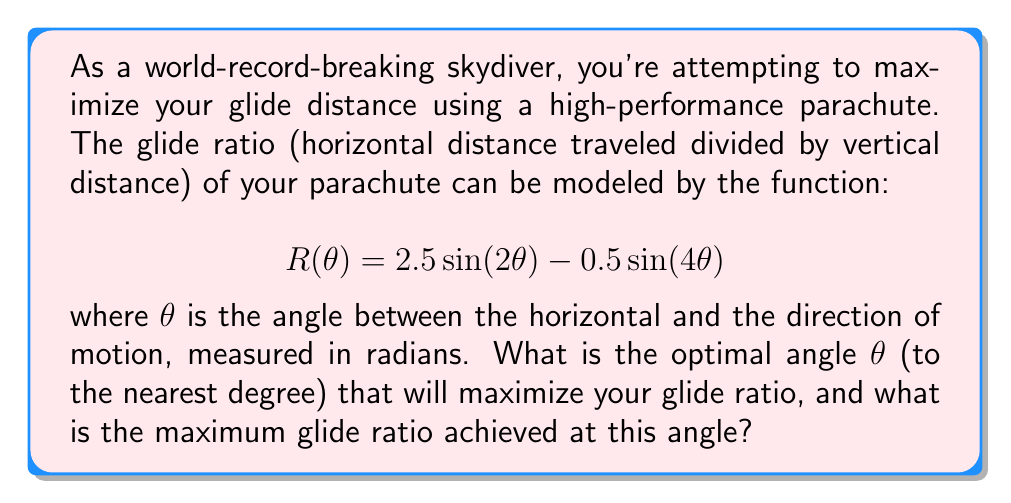Show me your answer to this math problem. To find the optimal angle that maximizes the glide ratio, we need to find the maximum value of the function $R(\theta)$. This can be done by following these steps:

1) First, we need to find the derivative of $R(\theta)$:
   $$R'(\theta) = 5\cos(2\theta) - 2\cos(4\theta)$$

2) To find the maximum, we set $R'(\theta) = 0$ and solve for $\theta$:
   $$5\cos(2\theta) - 2\cos(4\theta) = 0$$

3) Using the trigonometric identity $\cos(4\theta) = 2\cos^2(2\theta) - 1$, we can rewrite this as:
   $$5\cos(2\theta) - 2(2\cos^2(2\theta) - 1) = 0$$
   $$5\cos(2\theta) - 4\cos^2(2\theta) + 2 = 0$$

4) Let $u = \cos(2\theta)$. Then our equation becomes:
   $$5u - 4u^2 + 2 = 0$$
   $$4u^2 - 5u - 2 = 0$$

5) This is a quadratic equation. We can solve it using the quadratic formula:
   $$u = \frac{5 \pm \sqrt{25 + 32}}{8} = \frac{5 \pm \sqrt{57}}{8}$$

6) The positive solution is: $u = \frac{5 + \sqrt{57}}{8} \approx 1.3177$

7) Remember that $u = \cos(2\theta)$, so:
   $$2\theta = \arccos(1.3177)$$
   $$\theta = \frac{1}{2}\arccos(1.3177) \approx 0.4726 \text{ radians}$$

8) Converting to degrees: $0.4726 \text{ radians} \times \frac{180°}{\pi} \approx 27.1°$

9) To find the maximum glide ratio, we plug this value of $\theta$ back into our original function:
   $$R(0.4726) = 2.5\sin(2(0.4726)) - 0.5\sin(4(0.4726)) \approx 2.3541$$

Therefore, the optimal angle is approximately 27° (to the nearest degree), and the maximum glide ratio achieved at this angle is approximately 2.35.
Answer: The optimal angle is 27° and the maximum glide ratio is 2.35. 